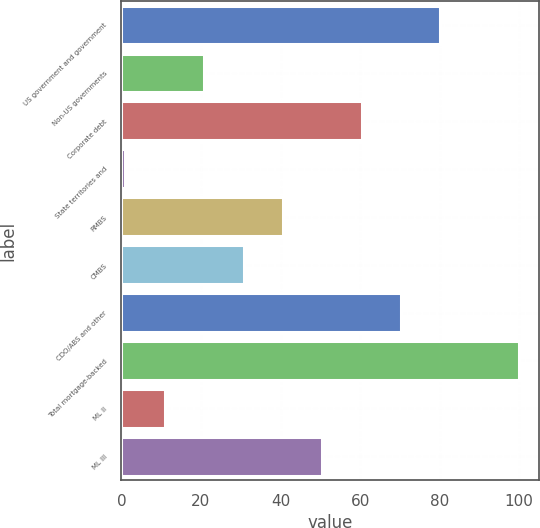<chart> <loc_0><loc_0><loc_500><loc_500><bar_chart><fcel>US government and government<fcel>Non-US governments<fcel>Corporate debt<fcel>State territories and<fcel>RMBS<fcel>CMBS<fcel>CDO/ABS and other<fcel>Total mortgage-backed<fcel>ML II<fcel>ML III<nl><fcel>80.2<fcel>20.8<fcel>60.4<fcel>1<fcel>40.6<fcel>30.7<fcel>70.3<fcel>100<fcel>10.9<fcel>50.5<nl></chart> 